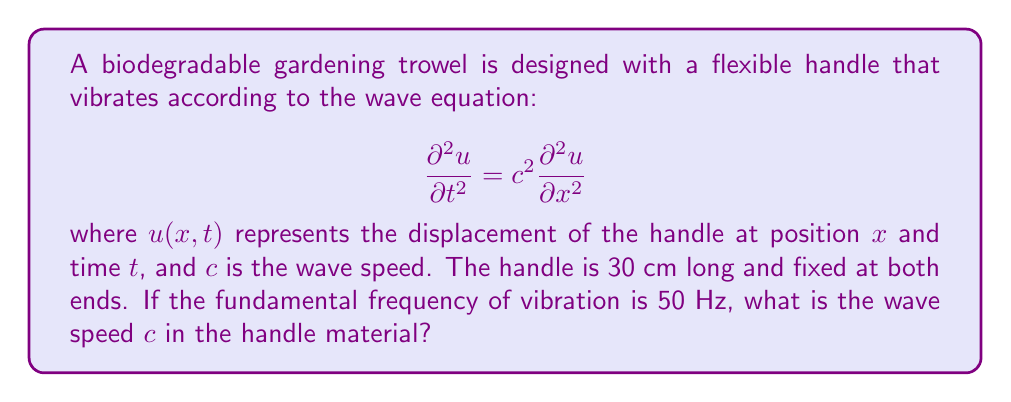Can you answer this question? To solve this problem, we'll follow these steps:

1) For a string fixed at both ends, the fundamental frequency $f_1$ is related to the length $L$ and wave speed $c$ by:

   $$f_1 = \frac{c}{2L}$$

2) We're given:
   - Fundamental frequency $f_1 = 50$ Hz
   - Length $L = 30$ cm $= 0.3$ m

3) Rearrange the equation to solve for $c$:

   $$c = 2Lf_1$$

4) Substitute the known values:

   $$c = 2 \times 0.3 \text{ m} \times 50 \text{ Hz}$$

5) Calculate:

   $$c = 30 \text{ m/s}$$

Thus, the wave speed in the handle material is 30 m/s.
Answer: 30 m/s 